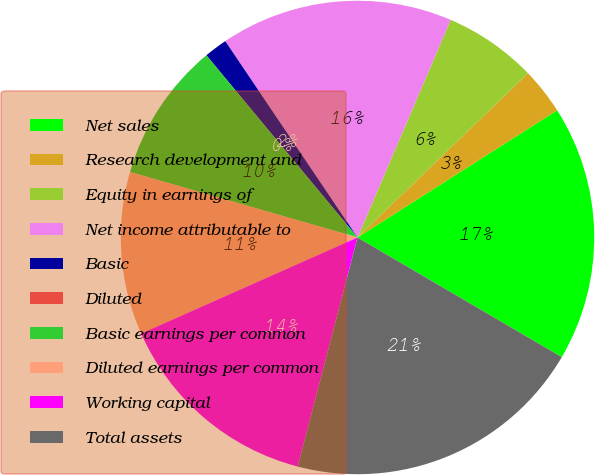Convert chart. <chart><loc_0><loc_0><loc_500><loc_500><pie_chart><fcel>Net sales<fcel>Research development and<fcel>Equity in earnings of<fcel>Net income attributable to<fcel>Basic<fcel>Diluted<fcel>Basic earnings per common<fcel>Diluted earnings per common<fcel>Working capital<fcel>Total assets<nl><fcel>17.46%<fcel>3.18%<fcel>6.35%<fcel>15.87%<fcel>1.59%<fcel>0.0%<fcel>9.52%<fcel>11.11%<fcel>14.28%<fcel>20.63%<nl></chart> 